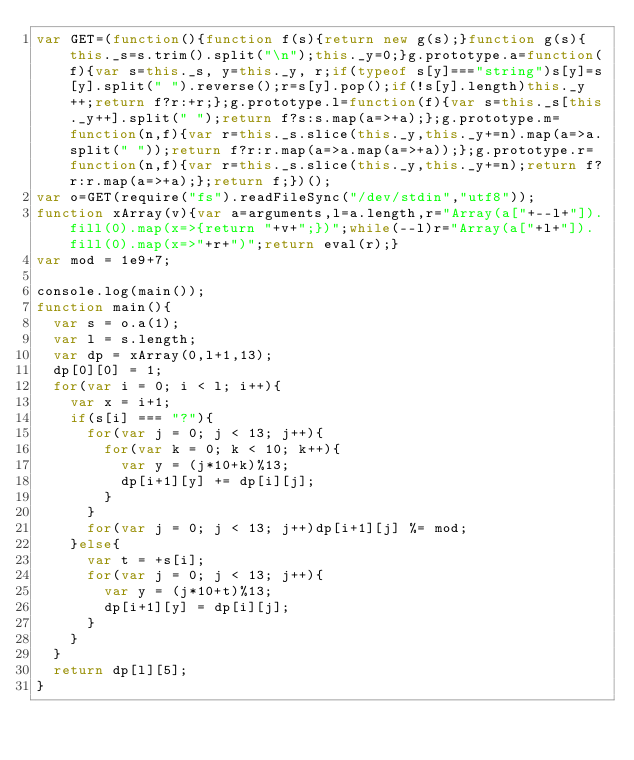<code> <loc_0><loc_0><loc_500><loc_500><_JavaScript_>var GET=(function(){function f(s){return new g(s);}function g(s){this._s=s.trim().split("\n");this._y=0;}g.prototype.a=function(f){var s=this._s, y=this._y, r;if(typeof s[y]==="string")s[y]=s[y].split(" ").reverse();r=s[y].pop();if(!s[y].length)this._y++;return f?r:+r;};g.prototype.l=function(f){var s=this._s[this._y++].split(" ");return f?s:s.map(a=>+a);};g.prototype.m=function(n,f){var r=this._s.slice(this._y,this._y+=n).map(a=>a.split(" "));return f?r:r.map(a=>a.map(a=>+a));};g.prototype.r=function(n,f){var r=this._s.slice(this._y,this._y+=n);return f?r:r.map(a=>+a);};return f;})();
var o=GET(require("fs").readFileSync("/dev/stdin","utf8"));
function xArray(v){var a=arguments,l=a.length,r="Array(a["+--l+"]).fill(0).map(x=>{return "+v+";})";while(--l)r="Array(a["+l+"]).fill(0).map(x=>"+r+")";return eval(r);}
var mod = 1e9+7;

console.log(main());
function main(){
  var s = o.a(1);
  var l = s.length;
  var dp = xArray(0,l+1,13);
  dp[0][0] = 1;
  for(var i = 0; i < l; i++){
    var x = i+1;
    if(s[i] === "?"){
      for(var j = 0; j < 13; j++){
        for(var k = 0; k < 10; k++){
          var y = (j*10+k)%13;
          dp[i+1][y] += dp[i][j];
        }
      }
      for(var j = 0; j < 13; j++)dp[i+1][j] %= mod;
    }else{
      var t = +s[i];
      for(var j = 0; j < 13; j++){
        var y = (j*10+t)%13;
        dp[i+1][y] = dp[i][j];
      }
    }
  }
  return dp[l][5];
}</code> 